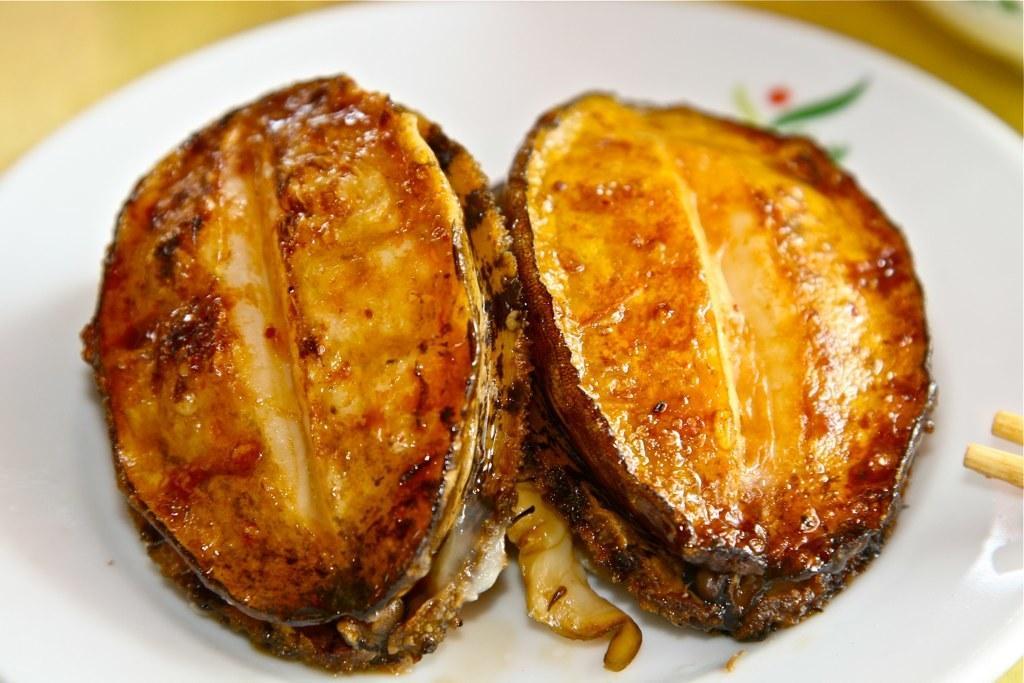Could you give a brief overview of what you see in this image? In this image I can see the plate with food. The plate is in white color and the food is in brown and black color. It is on the brown color surface and it is blurry. 